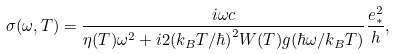<formula> <loc_0><loc_0><loc_500><loc_500>\sigma ( \omega , T ) = \frac { i \omega c } { \eta ( T ) \omega ^ { 2 } + i 2 ( k _ { B } T / \hbar { ) } ^ { 2 } W ( T ) g ( \hbar { \omega } / k _ { B } T ) } \frac { e _ { * } ^ { 2 } } { h } ,</formula> 